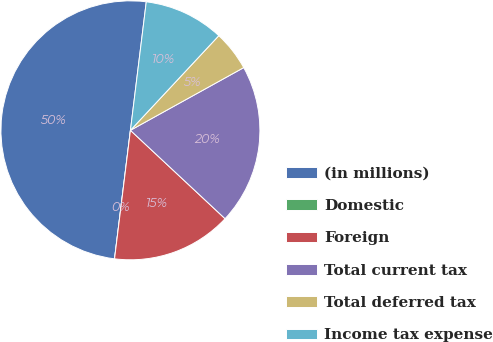<chart> <loc_0><loc_0><loc_500><loc_500><pie_chart><fcel>(in millions)<fcel>Domestic<fcel>Foreign<fcel>Total current tax<fcel>Total deferred tax<fcel>Income tax expense<nl><fcel>49.99%<fcel>0.0%<fcel>15.0%<fcel>20.0%<fcel>5.0%<fcel>10.0%<nl></chart> 